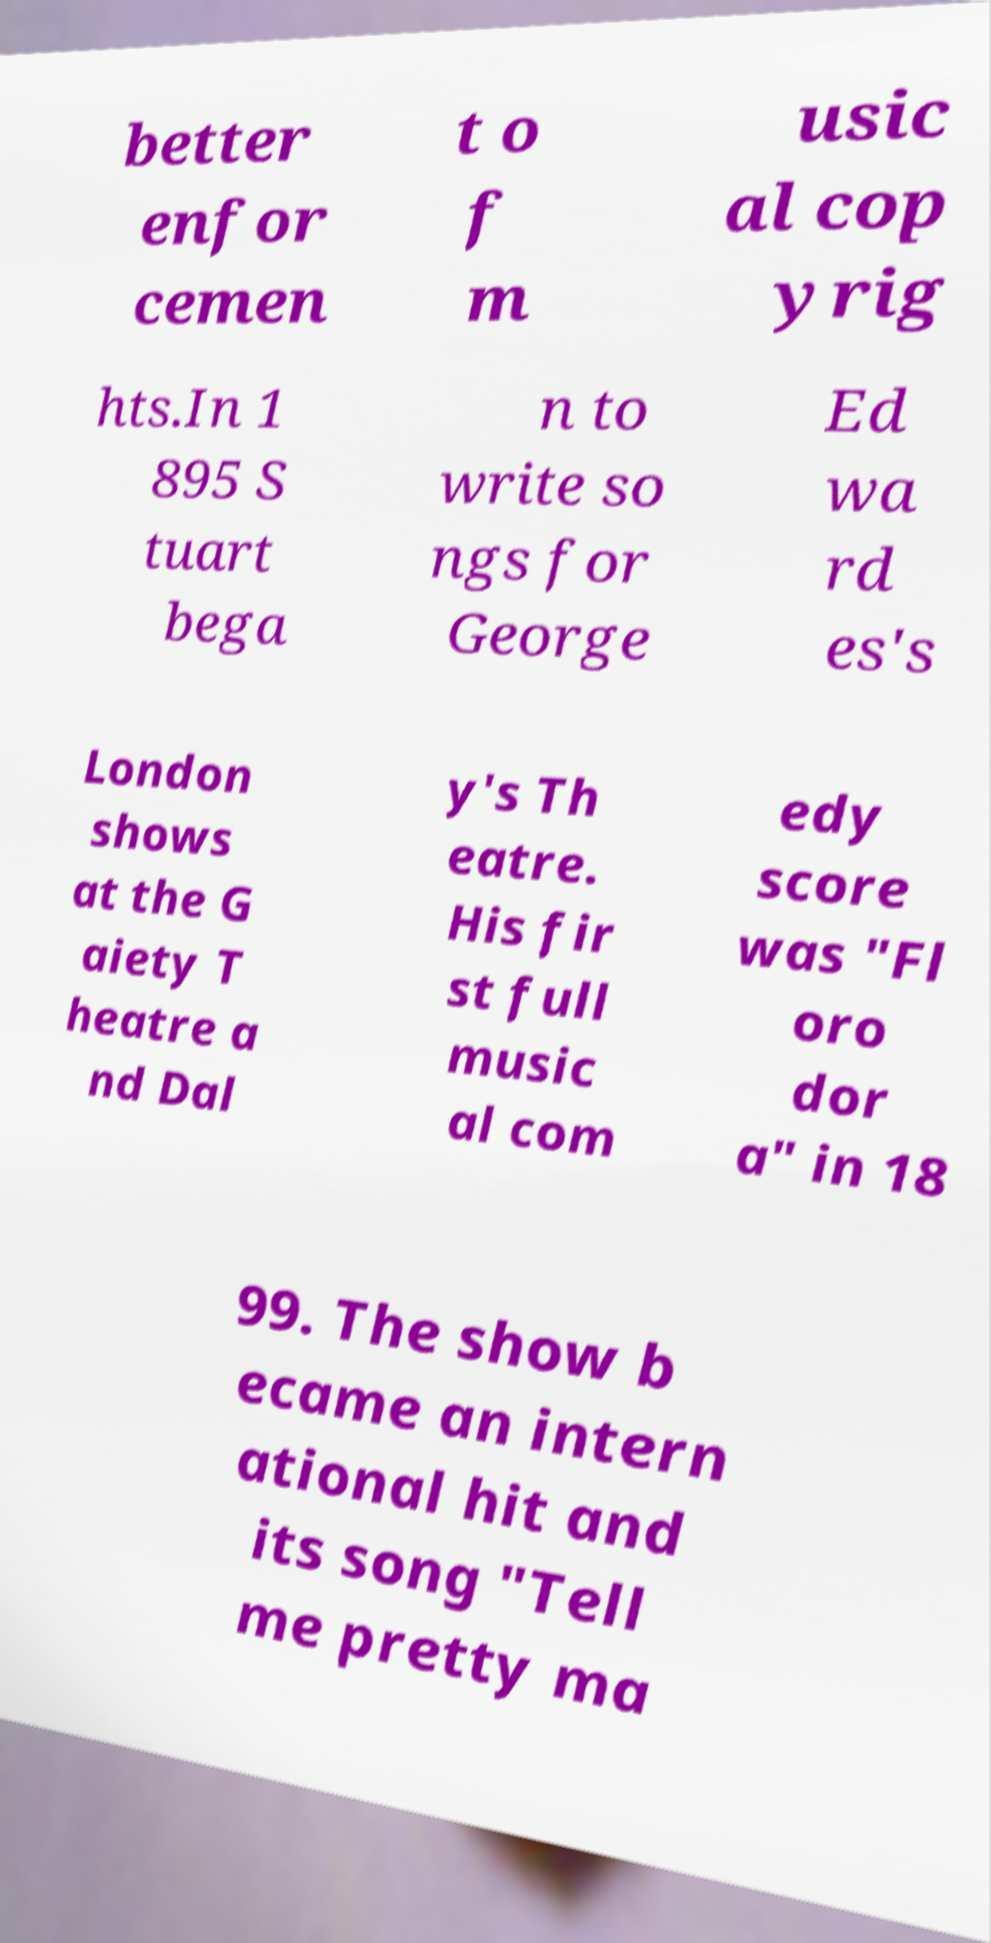Can you read and provide the text displayed in the image?This photo seems to have some interesting text. Can you extract and type it out for me? better enfor cemen t o f m usic al cop yrig hts.In 1 895 S tuart bega n to write so ngs for George Ed wa rd es's London shows at the G aiety T heatre a nd Dal y's Th eatre. His fir st full music al com edy score was "Fl oro dor a" in 18 99. The show b ecame an intern ational hit and its song "Tell me pretty ma 